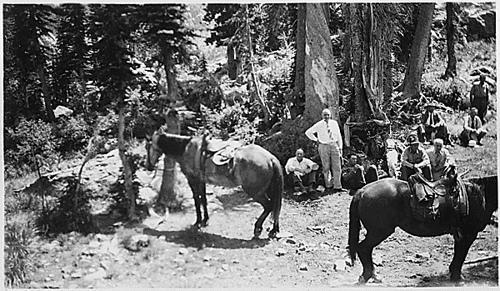Where are horses?
Short answer required. Forest. What color are the horses?
Quick response, please. Brown. Are the horses twins?
Keep it brief. No. What are those things on the horse's backs called?
Be succinct. Saddles. How many men are standing up?
Keep it brief. 1. Are the men sitting on the horses?
Quick response, please. No. 